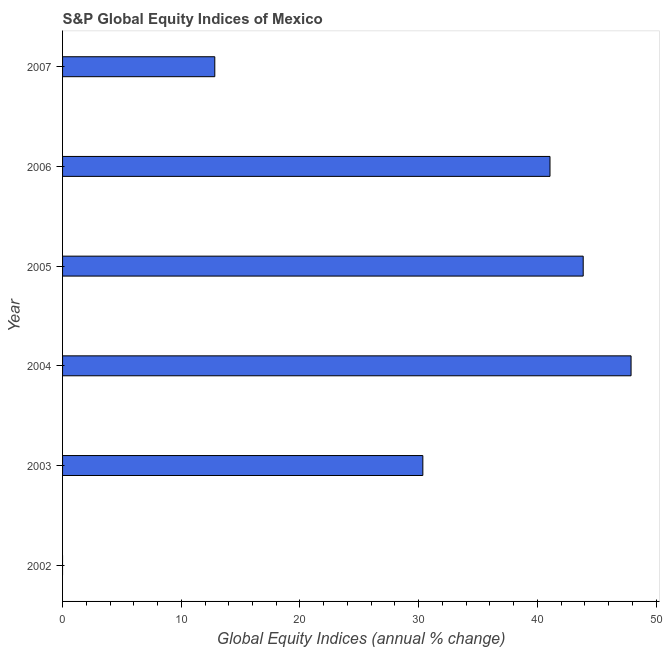Does the graph contain any zero values?
Your response must be concise. Yes. What is the title of the graph?
Keep it short and to the point. S&P Global Equity Indices of Mexico. What is the label or title of the X-axis?
Ensure brevity in your answer.  Global Equity Indices (annual % change). What is the label or title of the Y-axis?
Provide a short and direct response. Year. What is the s&p global equity indices in 2003?
Give a very brief answer. 30.35. Across all years, what is the maximum s&p global equity indices?
Provide a succinct answer. 47.89. Across all years, what is the minimum s&p global equity indices?
Offer a very short reply. 0. What is the sum of the s&p global equity indices?
Your answer should be very brief. 175.98. What is the difference between the s&p global equity indices in 2005 and 2006?
Provide a short and direct response. 2.8. What is the average s&p global equity indices per year?
Your answer should be very brief. 29.33. What is the median s&p global equity indices?
Your answer should be compact. 35.71. In how many years, is the s&p global equity indices greater than 42 %?
Ensure brevity in your answer.  2. What is the ratio of the s&p global equity indices in 2003 to that in 2006?
Make the answer very short. 0.74. What is the difference between the highest and the second highest s&p global equity indices?
Provide a short and direct response. 4.03. What is the difference between the highest and the lowest s&p global equity indices?
Make the answer very short. 47.89. In how many years, is the s&p global equity indices greater than the average s&p global equity indices taken over all years?
Your answer should be compact. 4. How many bars are there?
Provide a succinct answer. 5. How many years are there in the graph?
Offer a terse response. 6. What is the Global Equity Indices (annual % change) of 2003?
Your response must be concise. 30.35. What is the Global Equity Indices (annual % change) of 2004?
Offer a very short reply. 47.89. What is the Global Equity Indices (annual % change) of 2005?
Your response must be concise. 43.86. What is the Global Equity Indices (annual % change) of 2006?
Your answer should be very brief. 41.06. What is the Global Equity Indices (annual % change) in 2007?
Make the answer very short. 12.82. What is the difference between the Global Equity Indices (annual % change) in 2003 and 2004?
Keep it short and to the point. -17.54. What is the difference between the Global Equity Indices (annual % change) in 2003 and 2005?
Offer a very short reply. -13.51. What is the difference between the Global Equity Indices (annual % change) in 2003 and 2006?
Provide a succinct answer. -10.71. What is the difference between the Global Equity Indices (annual % change) in 2003 and 2007?
Provide a short and direct response. 17.53. What is the difference between the Global Equity Indices (annual % change) in 2004 and 2005?
Offer a terse response. 4.03. What is the difference between the Global Equity Indices (annual % change) in 2004 and 2006?
Your response must be concise. 6.83. What is the difference between the Global Equity Indices (annual % change) in 2004 and 2007?
Your answer should be very brief. 35.07. What is the difference between the Global Equity Indices (annual % change) in 2005 and 2006?
Make the answer very short. 2.8. What is the difference between the Global Equity Indices (annual % change) in 2005 and 2007?
Provide a succinct answer. 31.03. What is the difference between the Global Equity Indices (annual % change) in 2006 and 2007?
Offer a terse response. 28.24. What is the ratio of the Global Equity Indices (annual % change) in 2003 to that in 2004?
Give a very brief answer. 0.63. What is the ratio of the Global Equity Indices (annual % change) in 2003 to that in 2005?
Your response must be concise. 0.69. What is the ratio of the Global Equity Indices (annual % change) in 2003 to that in 2006?
Your answer should be very brief. 0.74. What is the ratio of the Global Equity Indices (annual % change) in 2003 to that in 2007?
Ensure brevity in your answer.  2.37. What is the ratio of the Global Equity Indices (annual % change) in 2004 to that in 2005?
Ensure brevity in your answer.  1.09. What is the ratio of the Global Equity Indices (annual % change) in 2004 to that in 2006?
Ensure brevity in your answer.  1.17. What is the ratio of the Global Equity Indices (annual % change) in 2004 to that in 2007?
Your answer should be compact. 3.73. What is the ratio of the Global Equity Indices (annual % change) in 2005 to that in 2006?
Offer a terse response. 1.07. What is the ratio of the Global Equity Indices (annual % change) in 2005 to that in 2007?
Give a very brief answer. 3.42. What is the ratio of the Global Equity Indices (annual % change) in 2006 to that in 2007?
Make the answer very short. 3.2. 